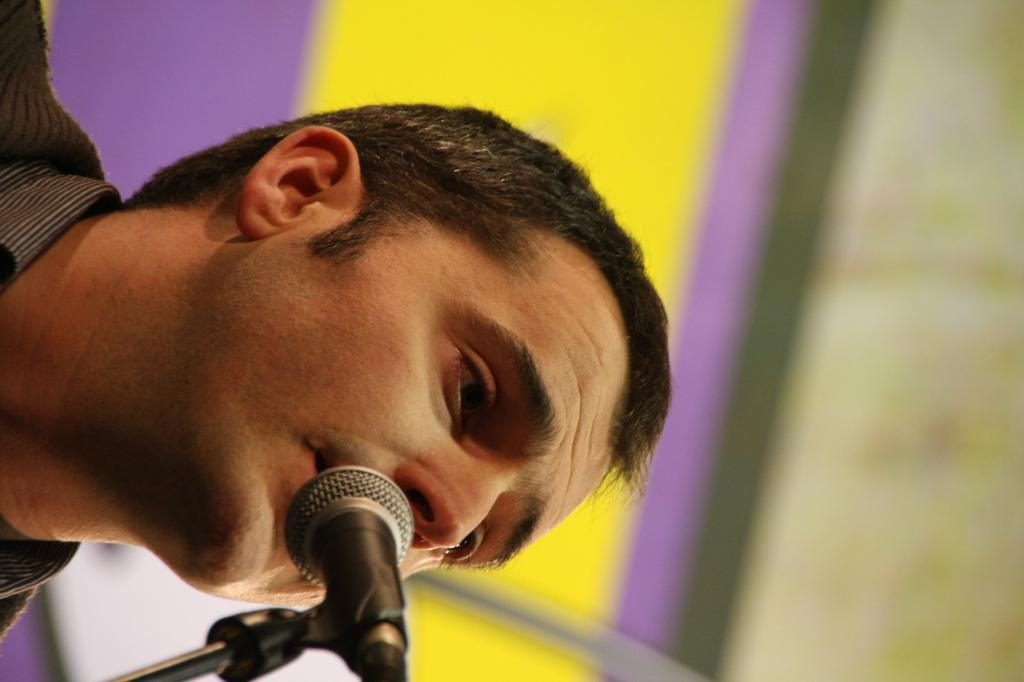What is the main subject of the image? There is a person in the image. What object is located in the foreground of the image? There is a microphone in the foreground of the image. What can be seen in the background of the image? There is a board in the background of the image. How would you describe the quality of the image? The image is blurry. What type of credit card is the person holding in the image? There is no credit card visible in the image; the person is not holding any object. 